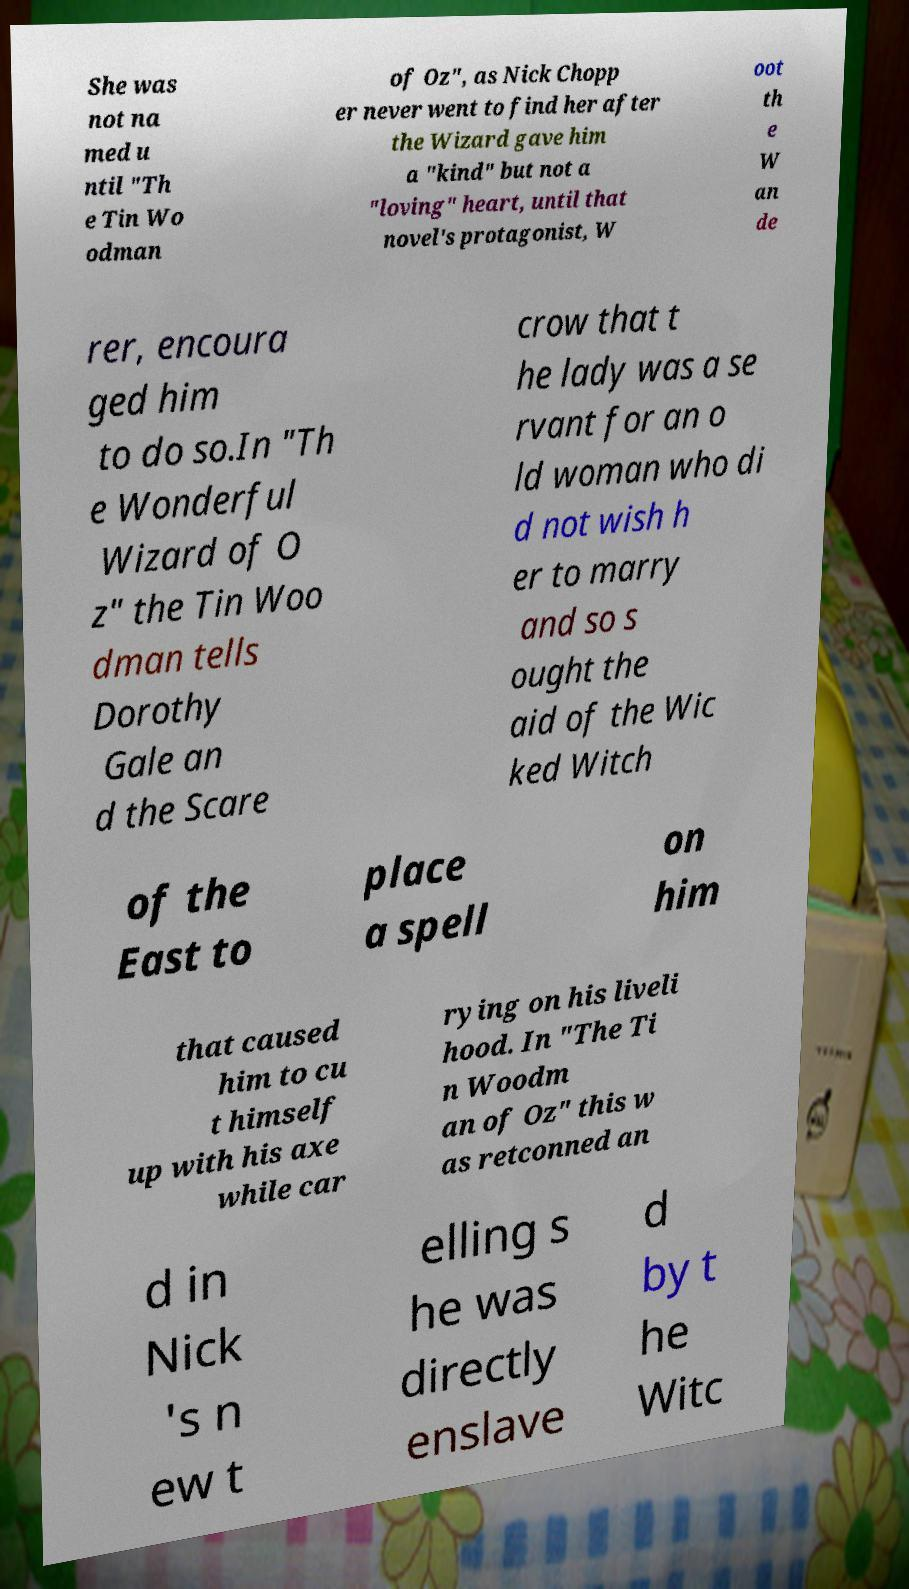Can you accurately transcribe the text from the provided image for me? She was not na med u ntil "Th e Tin Wo odman of Oz", as Nick Chopp er never went to find her after the Wizard gave him a "kind" but not a "loving" heart, until that novel's protagonist, W oot th e W an de rer, encoura ged him to do so.In "Th e Wonderful Wizard of O z" the Tin Woo dman tells Dorothy Gale an d the Scare crow that t he lady was a se rvant for an o ld woman who di d not wish h er to marry and so s ought the aid of the Wic ked Witch of the East to place a spell on him that caused him to cu t himself up with his axe while car rying on his liveli hood. In "The Ti n Woodm an of Oz" this w as retconned an d in Nick 's n ew t elling s he was directly enslave d by t he Witc 